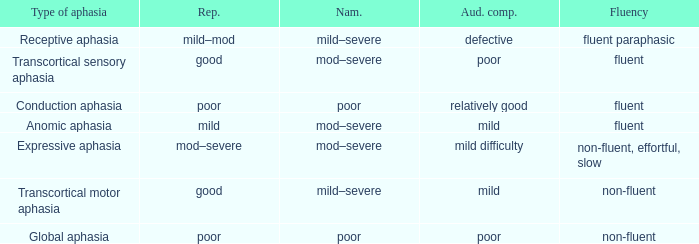Name the number of naming for anomic aphasia 1.0. 